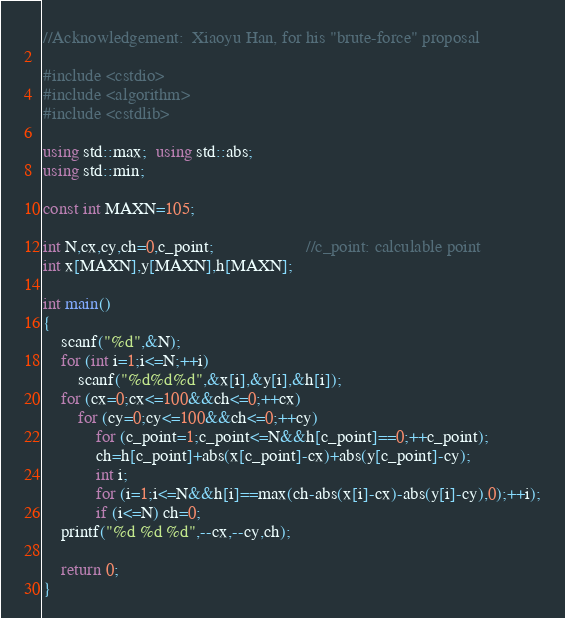Convert code to text. <code><loc_0><loc_0><loc_500><loc_500><_C++_>//Acknowledgement:  Xiaoyu Han, for his "brute-force" proposal

#include <cstdio>
#include <algorithm>
#include <cstdlib>

using std::max;  using std::abs;
using std::min;

const int MAXN=105;

int N,cx,cy,ch=0,c_point;                     //c_point: calculable point
int x[MAXN],y[MAXN],h[MAXN];

int main()
{
    scanf("%d",&N);
    for (int i=1;i<=N;++i)
        scanf("%d%d%d",&x[i],&y[i],&h[i]);
    for (cx=0;cx<=100&&ch<=0;++cx)
        for (cy=0;cy<=100&&ch<=0;++cy)
            for (c_point=1;c_point<=N&&h[c_point]==0;++c_point);
            ch=h[c_point]+abs(x[c_point]-cx)+abs(y[c_point]-cy);
            int i;
            for (i=1;i<=N&&h[i]==max(ch-abs(x[i]-cx)-abs(y[i]-cy),0);++i);
            if (i<=N) ch=0;
    printf("%d %d %d",--cx,--cy,ch);

    return 0;
}
</code> 